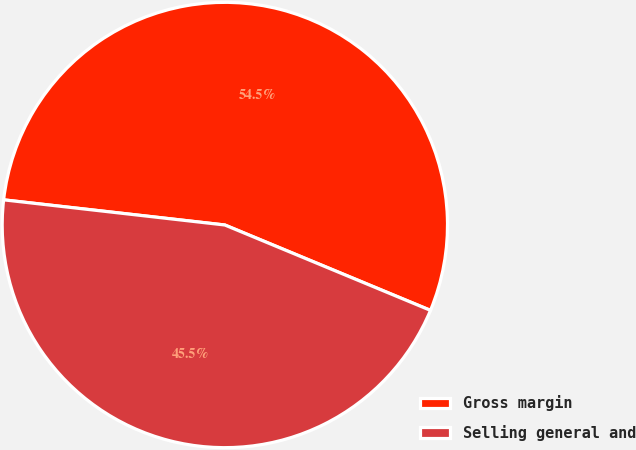<chart> <loc_0><loc_0><loc_500><loc_500><pie_chart><fcel>Gross margin<fcel>Selling general and<nl><fcel>54.46%<fcel>45.54%<nl></chart> 